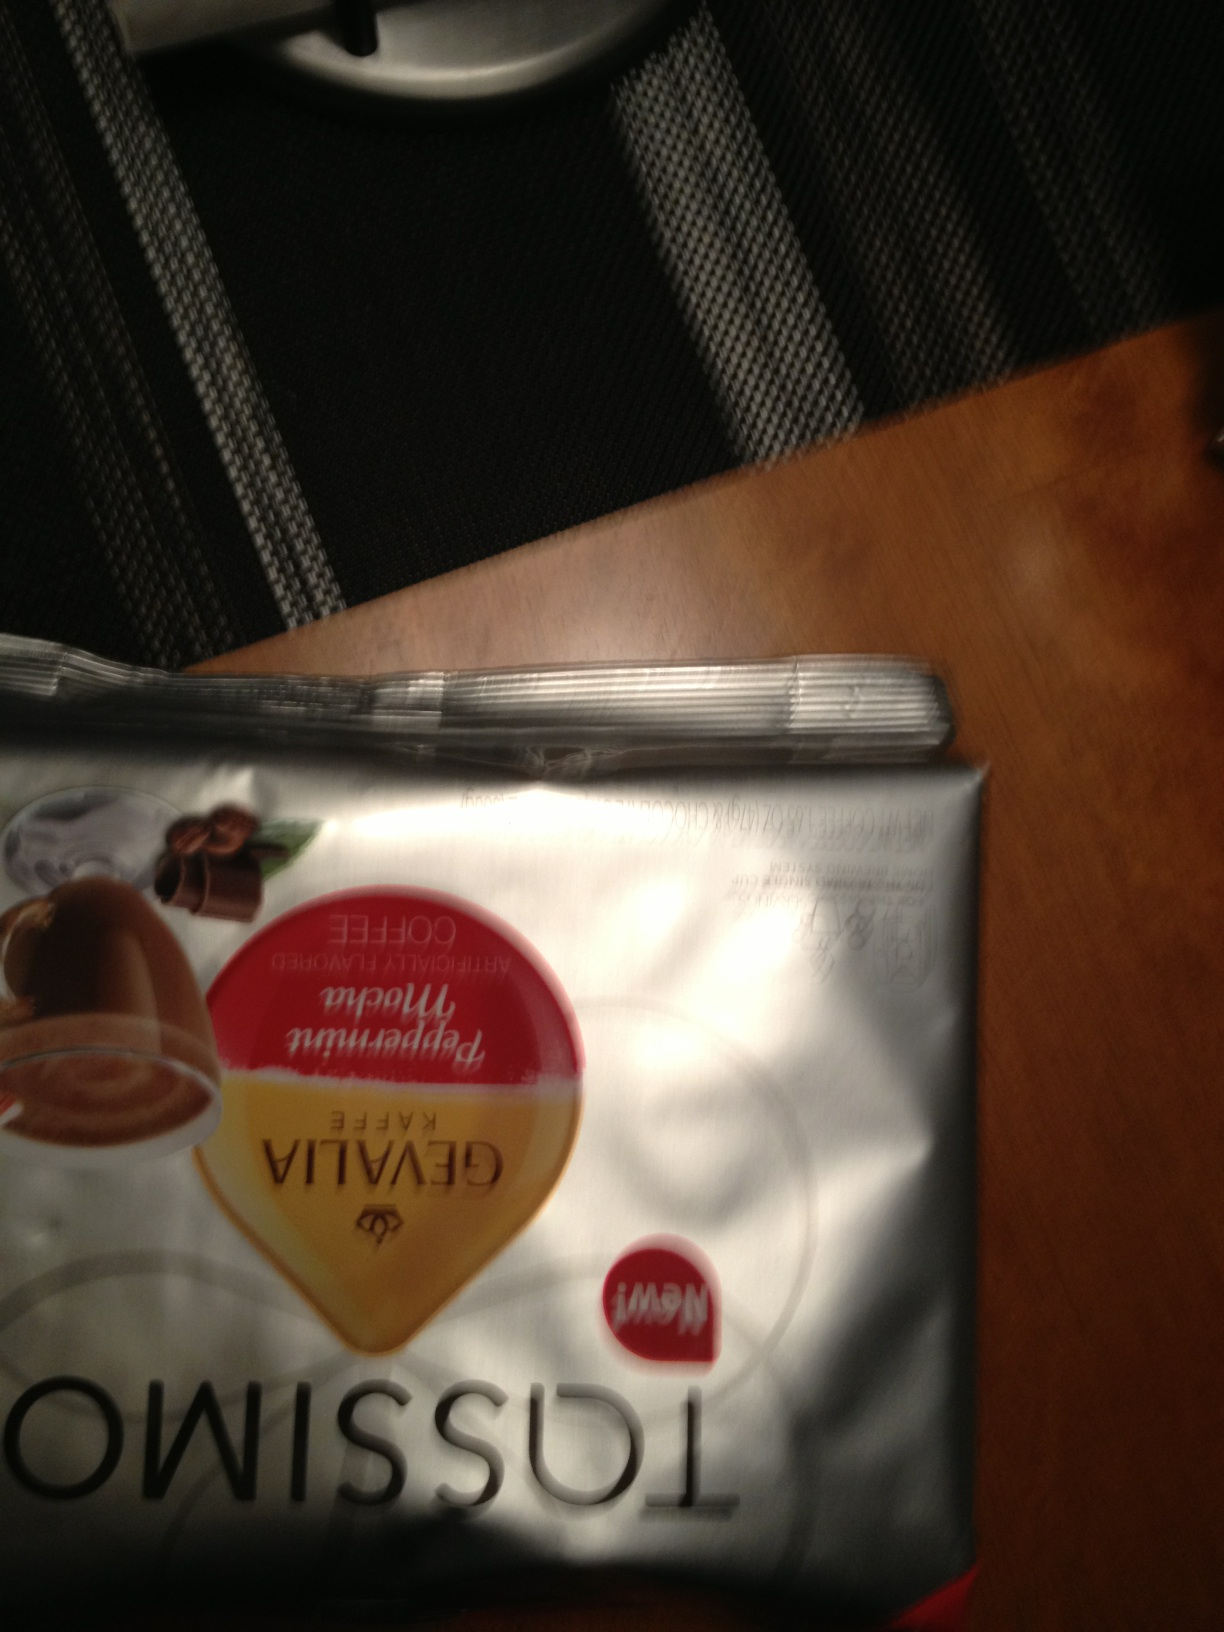Does this coffee have any certifications? The image shows a Rainforest Alliance Certified seal, which means that the coffee has been produced following sustainable farming practices that help to conserve biodiversity and ensure sustainable livelihoods for the farmers and local communities. 